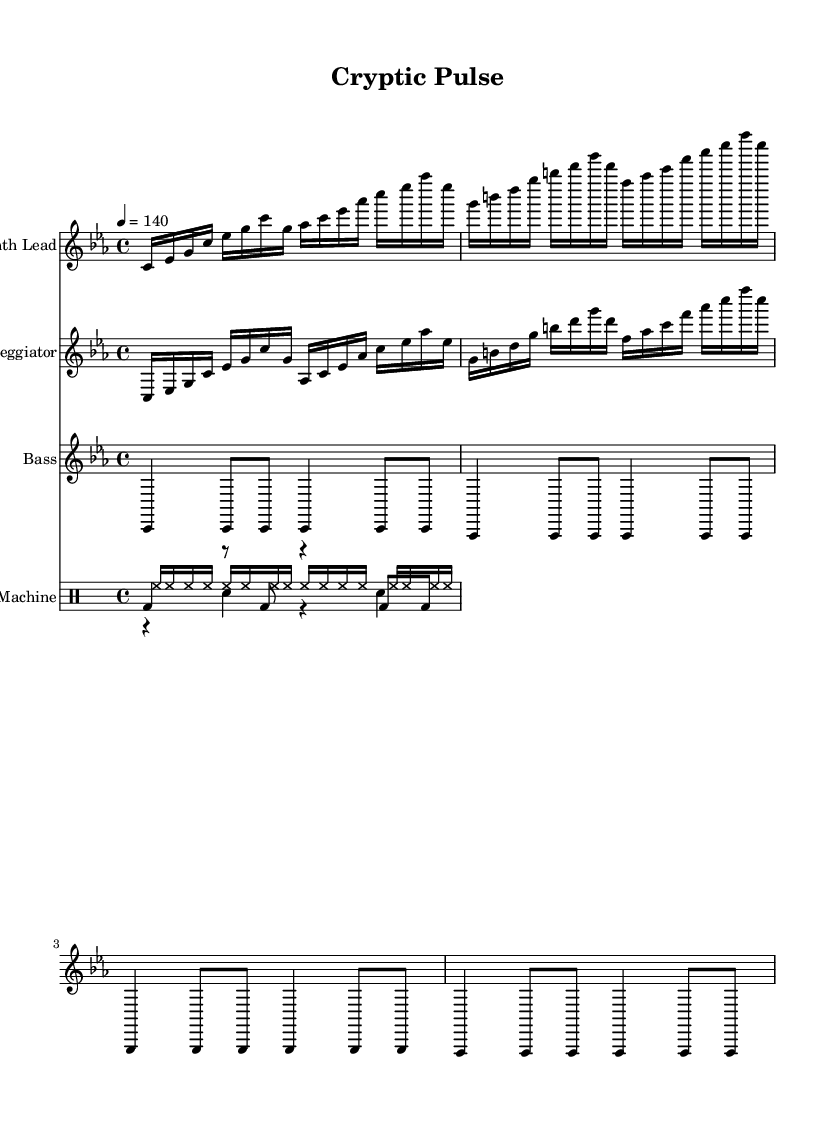What is the key signature of this music? The key signature is C minor, which has three flats (B flat, E flat, and A flat). It's indicated at the beginning of the staff with the proper symbol for C minor (B♭, E♭, A♭).
Answer: C minor What is the time signature of this music? The time signature is 4/4, which means there are four beats in each measure and the quarter note receives one beat. This is shown at the beginning of the score.
Answer: 4/4 What is the tempo marking of this piece? The tempo marking is 140, indicated above the staff as "4 = 140", signifying that a quarter note equals 140 beats per minute.
Answer: 140 How many musical voices are used in this composition? There are four musical voices: Synth Lead, Arpeggiator, Bass, and Drum Machine. Each is represented by a distinct staff in the score.
Answer: Four Which instrument plays the bass line in this piece? The bass line is played by the Bass instrument, which is clearly labeled at the beginning of its staff in the sheet music.
Answer: Bass What type of rhythm does the drum machine employ? The drum machine employs a combination of bass drum, snare drum, and hi-hat patterns typical of electronic music, with varied note durations creating a complex, energetic rhythm.
Answer: Complex rhythm How is the lead melody structured in terms of notes? The lead melody consists of a sequence of sixteenth notes, emphasizing a repetitive and intricate pattern, which is characteristic of electronic music, mimicking algorithmic structures.
Answer: Repetitive sixteenth notes 